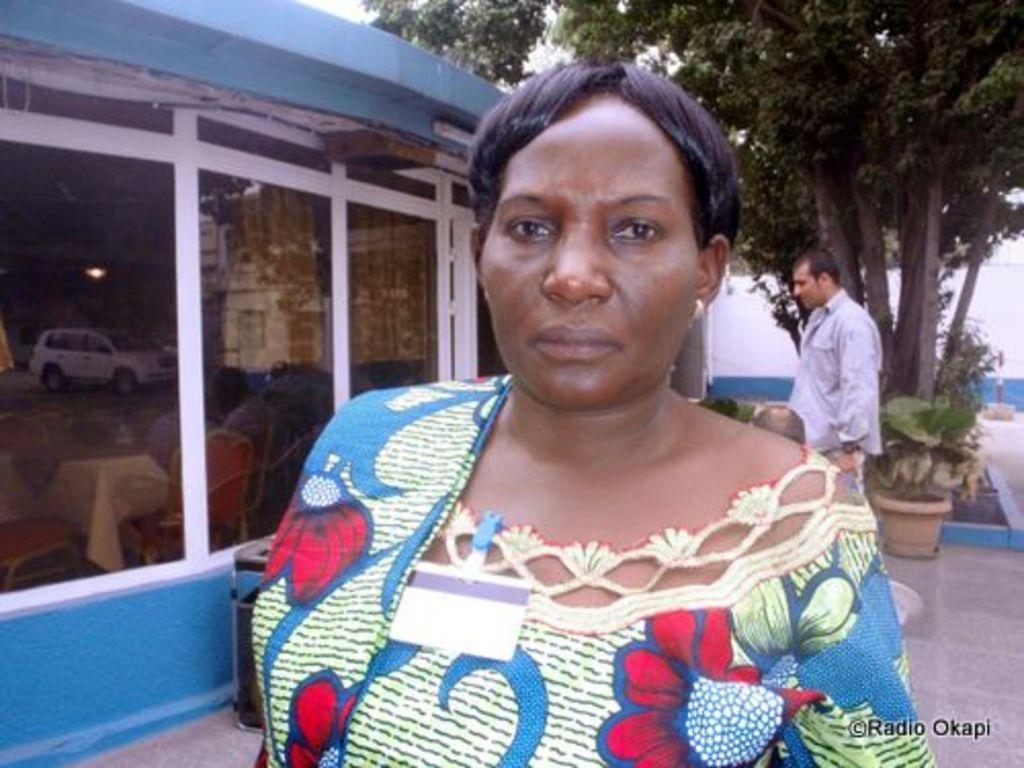How many people are present in the image? There are two people, a woman and a man, present in the image. What are the positions of the woman and the man in the image? Both the woman and the man are standing on the floor in the image. What can be seen in the background of the image? There are trees, houseplants, buildings, and the sky visible in the background of the image. What type of net can be seen hanging from the hook in the image? There is no net or hook present in the image. What color is the van parked in front of the building in the image? There is no van present in the image; only the woman, the man, and the background elements are visible. 